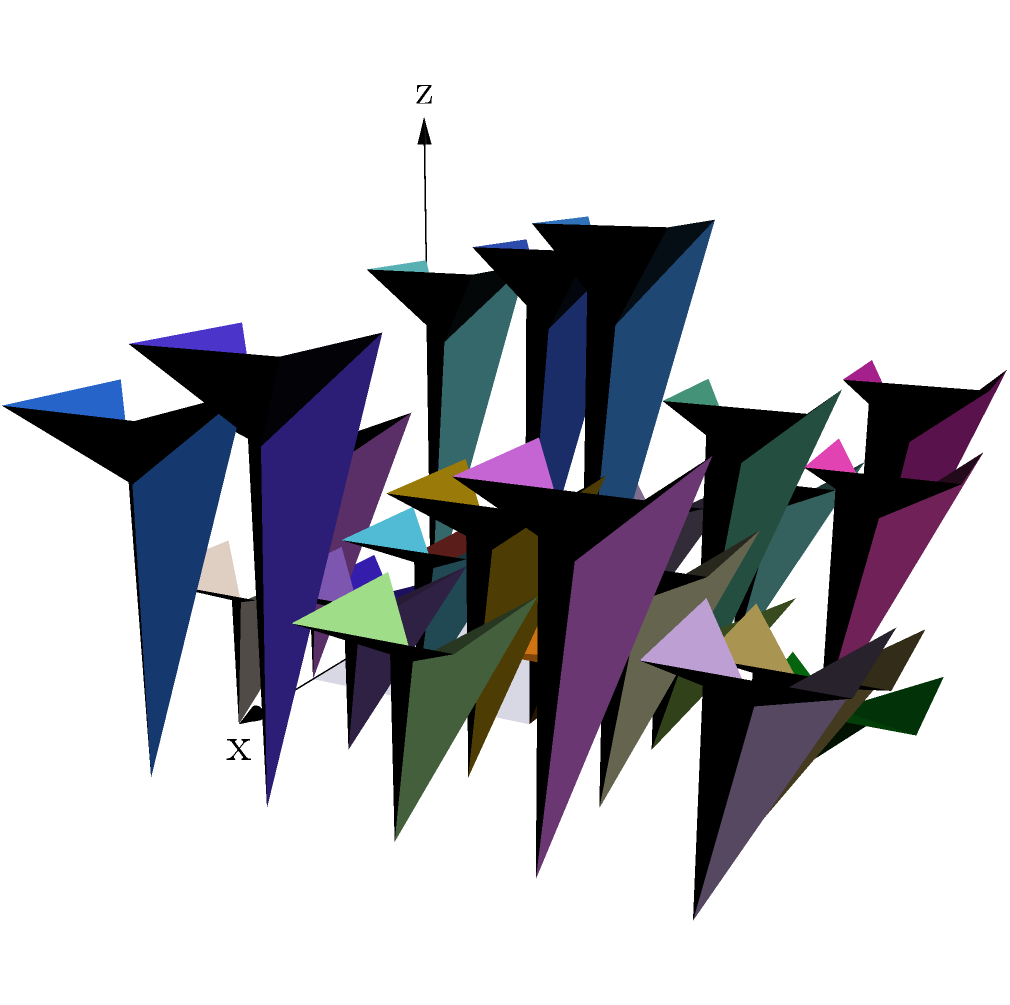In the context of analyzing futuristic cityscapes in science fiction novels, consider the 3D model shown above. If this cityscape is rotated 90 degrees clockwise around the z-axis, which axis will the tallest building be closest to after the rotation? To solve this problem, let's follow these steps:

1. Observe the current orientation:
   - The x-axis points to the right
   - The y-axis points to the back
   - The z-axis points upward

2. Identify the tallest building:
   - The tallest building appears to be in the front-right corner of the cityscape

3. Understand the rotation:
   - A 90-degree clockwise rotation around the z-axis means the cityscape will turn to the right when viewed from above

4. Visualize the rotation:
   - The front-right corner (where the tallest building is) will move to the back-right corner
   - The x-axis will now point to where the negative y-axis was
   - The y-axis will now point to where the positive x-axis was

5. Determine the new position of the tallest building:
   - After rotation, the tallest building will be closest to the negative y-axis in its new position

This analysis demonstrates how spatial transformations in futuristic cityscapes can be used to explore themes of perspective and change in science fiction narratives, a technique that might be compared to the use of shifting viewpoints in crime fiction to reveal or conceal information.
Answer: Negative y-axis 